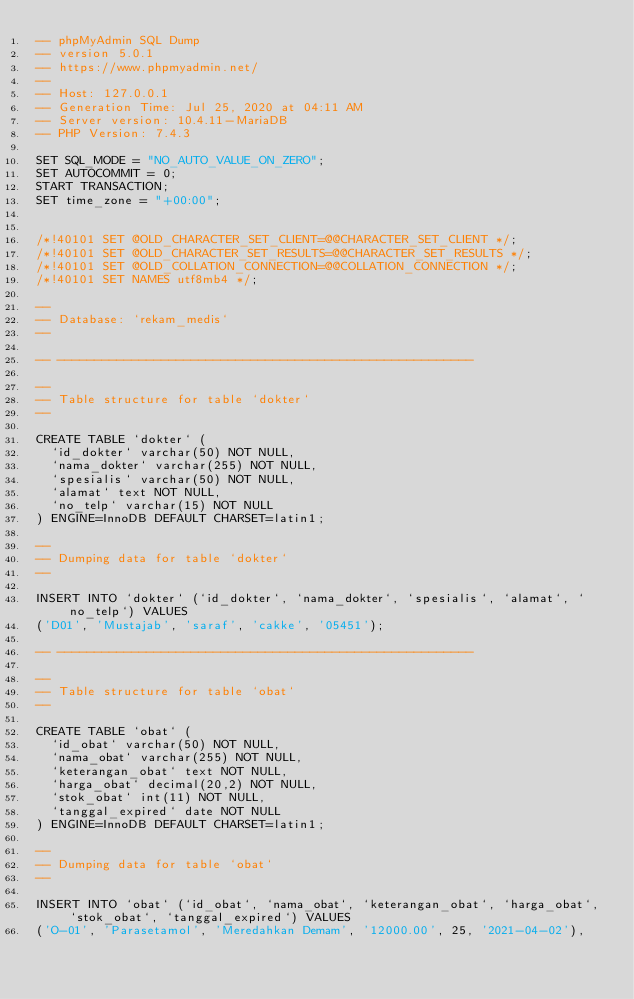<code> <loc_0><loc_0><loc_500><loc_500><_SQL_>-- phpMyAdmin SQL Dump
-- version 5.0.1
-- https://www.phpmyadmin.net/
--
-- Host: 127.0.0.1
-- Generation Time: Jul 25, 2020 at 04:11 AM
-- Server version: 10.4.11-MariaDB
-- PHP Version: 7.4.3

SET SQL_MODE = "NO_AUTO_VALUE_ON_ZERO";
SET AUTOCOMMIT = 0;
START TRANSACTION;
SET time_zone = "+00:00";


/*!40101 SET @OLD_CHARACTER_SET_CLIENT=@@CHARACTER_SET_CLIENT */;
/*!40101 SET @OLD_CHARACTER_SET_RESULTS=@@CHARACTER_SET_RESULTS */;
/*!40101 SET @OLD_COLLATION_CONNECTION=@@COLLATION_CONNECTION */;
/*!40101 SET NAMES utf8mb4 */;

--
-- Database: `rekam_medis`
--

-- --------------------------------------------------------

--
-- Table structure for table `dokter`
--

CREATE TABLE `dokter` (
  `id_dokter` varchar(50) NOT NULL,
  `nama_dokter` varchar(255) NOT NULL,
  `spesialis` varchar(50) NOT NULL,
  `alamat` text NOT NULL,
  `no_telp` varchar(15) NOT NULL
) ENGINE=InnoDB DEFAULT CHARSET=latin1;

--
-- Dumping data for table `dokter`
--

INSERT INTO `dokter` (`id_dokter`, `nama_dokter`, `spesialis`, `alamat`, `no_telp`) VALUES
('D01', 'Mustajab', 'saraf', 'cakke', '05451');

-- --------------------------------------------------------

--
-- Table structure for table `obat`
--

CREATE TABLE `obat` (
  `id_obat` varchar(50) NOT NULL,
  `nama_obat` varchar(255) NOT NULL,
  `keterangan_obat` text NOT NULL,
  `harga_obat` decimal(20,2) NOT NULL,
  `stok_obat` int(11) NOT NULL,
  `tanggal_expired` date NOT NULL
) ENGINE=InnoDB DEFAULT CHARSET=latin1;

--
-- Dumping data for table `obat`
--

INSERT INTO `obat` (`id_obat`, `nama_obat`, `keterangan_obat`, `harga_obat`, `stok_obat`, `tanggal_expired`) VALUES
('O-01', 'Parasetamol', 'Meredahkan Demam', '12000.00', 25, '2021-04-02'),</code> 